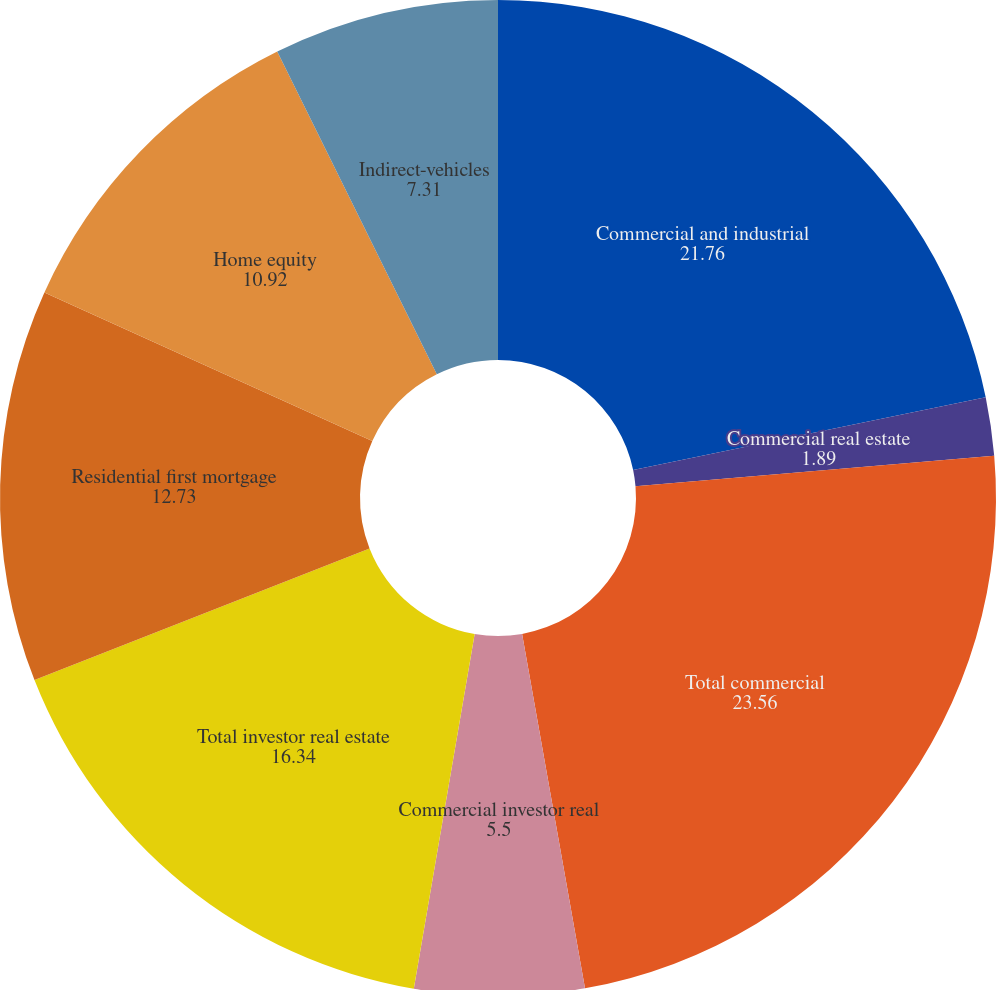Convert chart. <chart><loc_0><loc_0><loc_500><loc_500><pie_chart><fcel>Commercial and industrial<fcel>Commercial real estate<fcel>Total commercial<fcel>Commercial investor real<fcel>Total investor real estate<fcel>Residential first mortgage<fcel>Home equity<fcel>Indirect-vehicles<nl><fcel>21.76%<fcel>1.89%<fcel>23.56%<fcel>5.5%<fcel>16.34%<fcel>12.73%<fcel>10.92%<fcel>7.31%<nl></chart> 